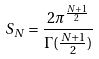<formula> <loc_0><loc_0><loc_500><loc_500>S _ { N } = \frac { 2 \pi ^ { \frac { N + 1 } { 2 } } } { \Gamma ( \frac { N + 1 } { 2 } ) }</formula> 